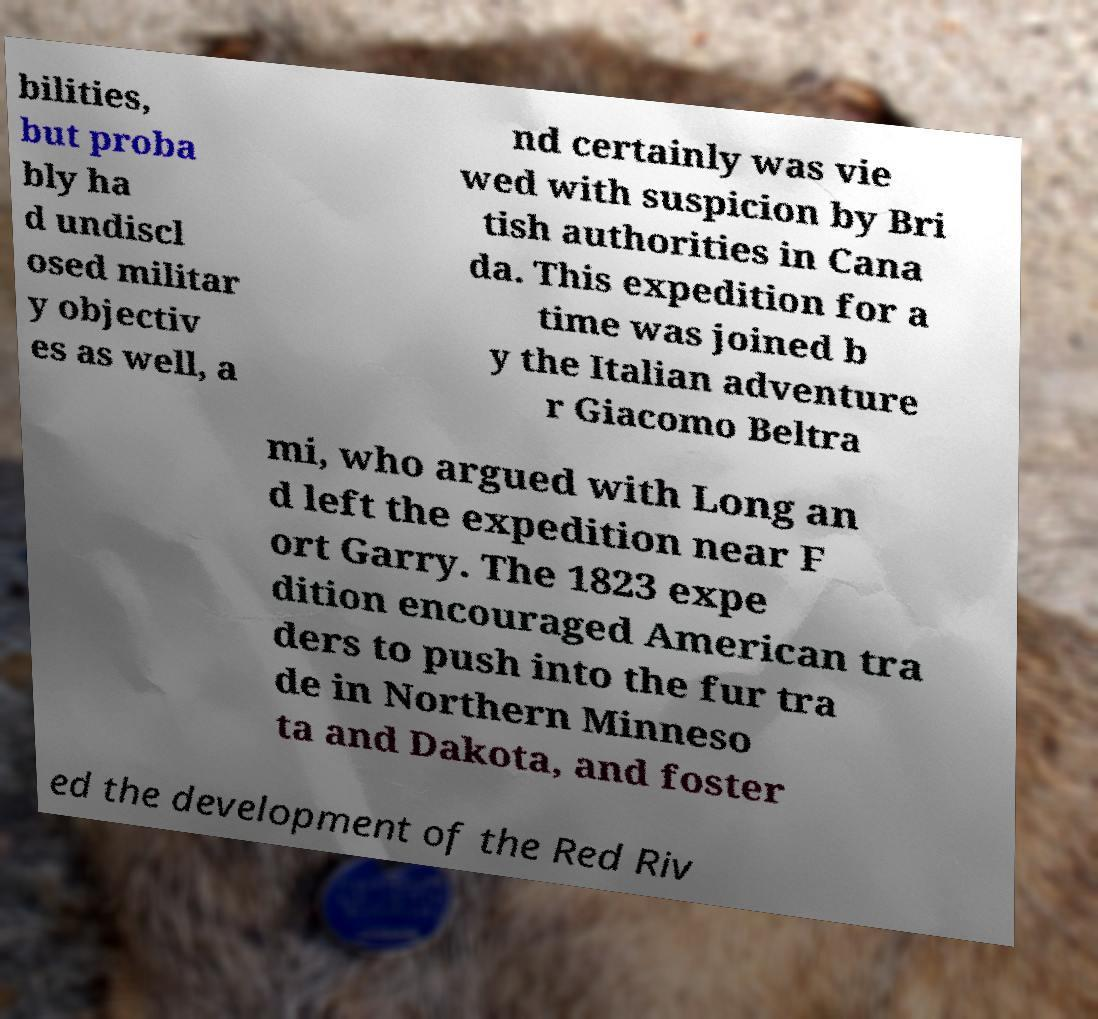Can you accurately transcribe the text from the provided image for me? bilities, but proba bly ha d undiscl osed militar y objectiv es as well, a nd certainly was vie wed with suspicion by Bri tish authorities in Cana da. This expedition for a time was joined b y the Italian adventure r Giacomo Beltra mi, who argued with Long an d left the expedition near F ort Garry. The 1823 expe dition encouraged American tra ders to push into the fur tra de in Northern Minneso ta and Dakota, and foster ed the development of the Red Riv 